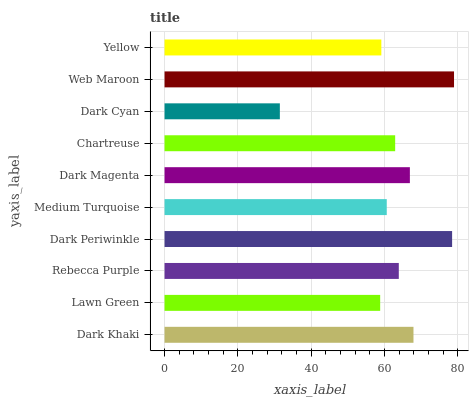Is Dark Cyan the minimum?
Answer yes or no. Yes. Is Web Maroon the maximum?
Answer yes or no. Yes. Is Lawn Green the minimum?
Answer yes or no. No. Is Lawn Green the maximum?
Answer yes or no. No. Is Dark Khaki greater than Lawn Green?
Answer yes or no. Yes. Is Lawn Green less than Dark Khaki?
Answer yes or no. Yes. Is Lawn Green greater than Dark Khaki?
Answer yes or no. No. Is Dark Khaki less than Lawn Green?
Answer yes or no. No. Is Rebecca Purple the high median?
Answer yes or no. Yes. Is Chartreuse the low median?
Answer yes or no. Yes. Is Dark Periwinkle the high median?
Answer yes or no. No. Is Dark Magenta the low median?
Answer yes or no. No. 